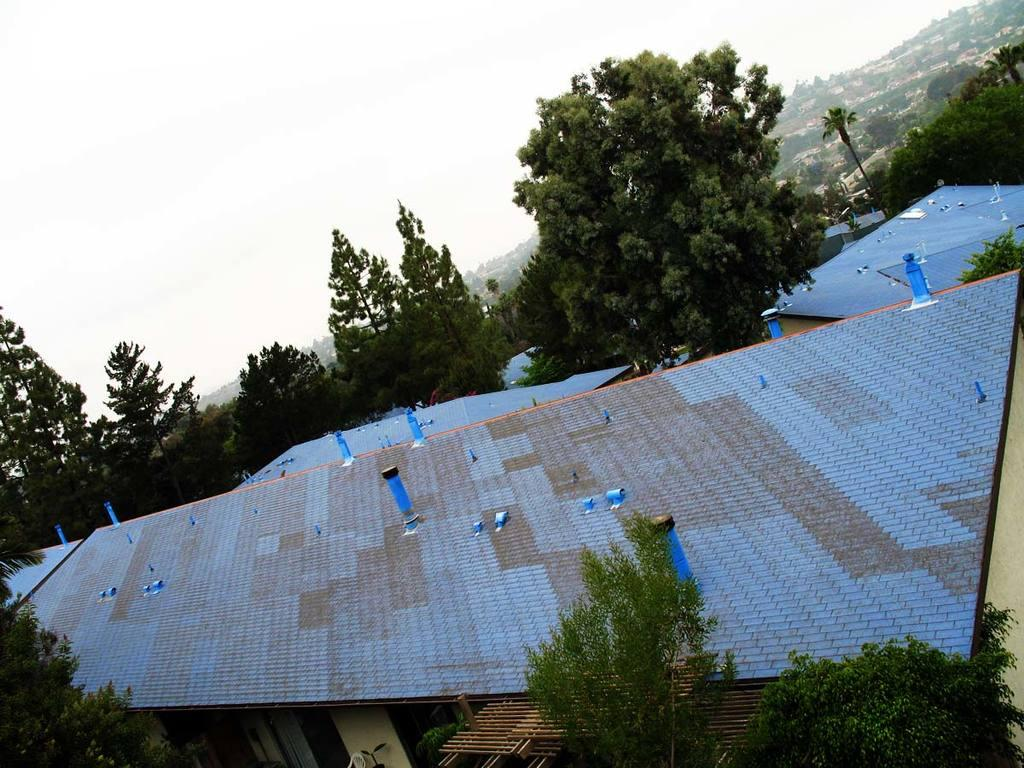What type of structures can be seen in the image? There are houses in the image. What other elements are present in the image besides houses? There are rooftops and trees visible in the image. What can be seen in the background of the image? The sky is visible in the background of the image. Where is the mitten located in the image? There is no mitten present in the image. What type of nest can be seen in the trees in the image? There is no nest visible in the trees in the image. 